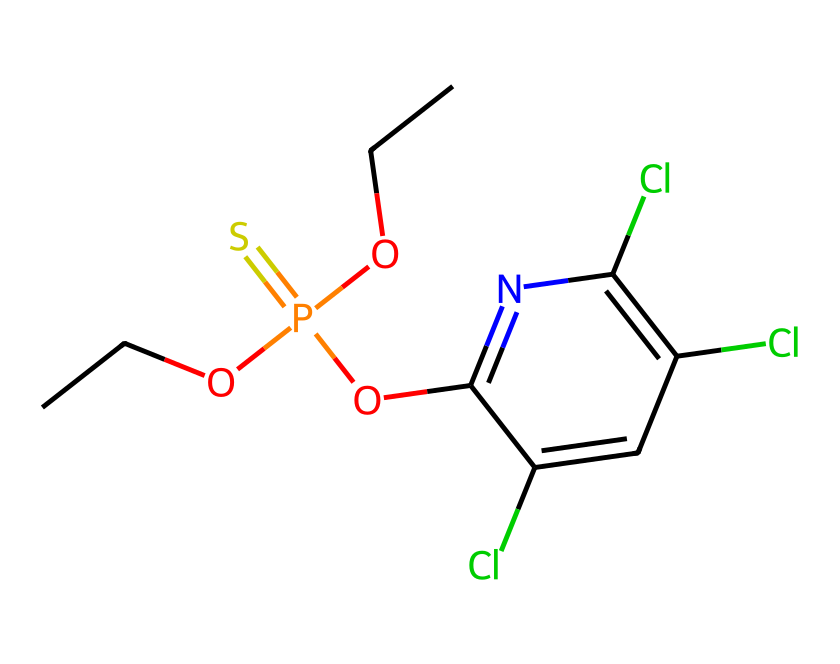What is the molecular formula of chlorpyrifos? The molecular formula can be derived from the SMILES representation by counting each type of atom represented: there are 9 carbons (C), 10 hydrogens (H), 4 chlorines (Cl), 1 phosphorus (P), and 1 oxygen (O). Thus, the molecular formula is C9H10Cl3NO3PS.
Answer: C9H10Cl3NO3PS How many chlorines are present in chlorpyrifos? By examining the SMILES representation, we see the 'Cl' symbols directly indicate each chlorine atom. There are three occurrences of 'Cl'.
Answer: three Which elements in chlorpyrifos contribute to its toxicity? The phosphorus (P) atom and the chlorine (Cl) atoms are primarily responsible for the toxic effects of chlorpyrifos, as phosphorothioates are known to inhibit acetylcholinesterase, and chlorines may contribute to its reactivity.
Answer: phosphorus, chlorine What functional groups are present in chlorpyrifos? Analyzing the SMILES, we see there is an alkoxy group (due to 'OCC'), a phosphate group (P(=S)(OCC)), and a chloro-substituted aromatic ring indicating various functional groups. These suggest the reactivity characteristic of pesticides.
Answer: alkoxy, phosphate Why does chlorpyrifos inhibit acetylcholinesterase? The structure of chlorpyrifos contains a phosphorus atom connected to a sulfur atom (the 'P(=S)') which plays a role in mimicking the natural substrate of acetylcholinesterase, thus interfering with its activity. This structural motility allows it to fit into the enzyme’s active site, blocking its function.
Answer: phosphorus, sulfur 